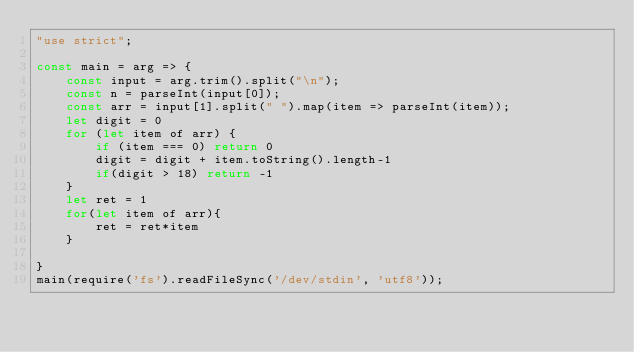Convert code to text. <code><loc_0><loc_0><loc_500><loc_500><_JavaScript_>"use strict";

const main = arg => {
    const input = arg.trim().split("\n");
    const n = parseInt(input[0]);
    const arr = input[1].split(" ").map(item => parseInt(item));
    let digit = 0
    for (let item of arr) {
        if (item === 0) return 0
        digit = digit + item.toString().length-1
        if(digit > 18) return -1
    }
    let ret = 1
    for(let item of arr){
        ret = ret*item
    }

}
main(require('fs').readFileSync('/dev/stdin', 'utf8'));  
</code> 